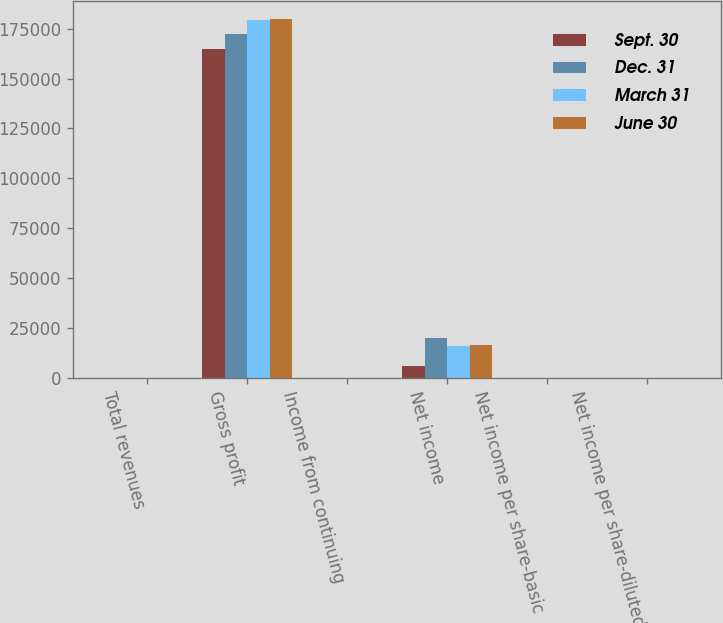<chart> <loc_0><loc_0><loc_500><loc_500><stacked_bar_chart><ecel><fcel>Total revenues<fcel>Gross profit<fcel>Income from continuing<fcel>Net income<fcel>Net income per share-basic<fcel>Net income per share-diluted<nl><fcel>Sept. 30<fcel>0.235<fcel>164752<fcel>0.15<fcel>6122<fcel>0.07<fcel>0.07<nl><fcel>Dec. 31<fcel>0.235<fcel>172313<fcel>0.23<fcel>19989<fcel>0.24<fcel>0.23<nl><fcel>March 31<fcel>0.235<fcel>179255<fcel>0.18<fcel>15697<fcel>0.19<fcel>0.18<nl><fcel>June 30<fcel>0.235<fcel>179878<fcel>0.18<fcel>16484<fcel>0.19<fcel>0.19<nl></chart> 